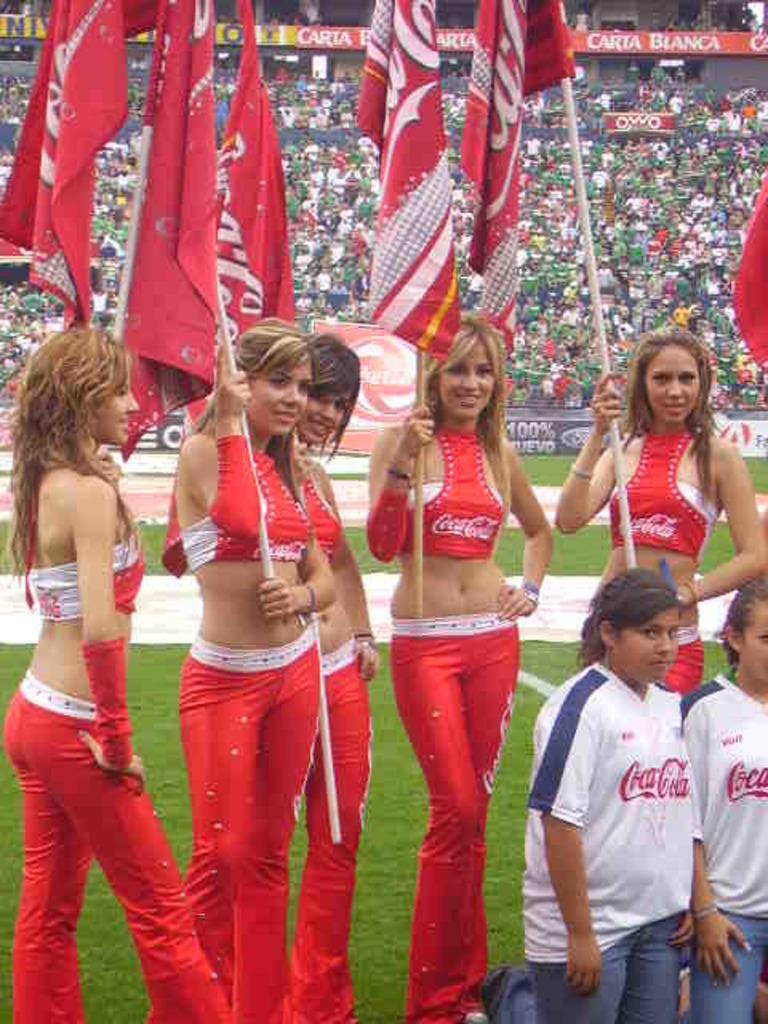Provide a one-sentence caption for the provided image. Both the beautiful ladies and the younger kids are wearing tops sponsored by Coca-cola. 